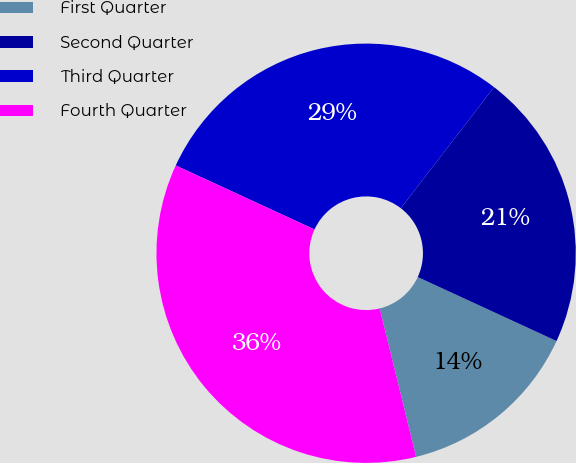<chart> <loc_0><loc_0><loc_500><loc_500><pie_chart><fcel>First Quarter<fcel>Second Quarter<fcel>Third Quarter<fcel>Fourth Quarter<nl><fcel>14.29%<fcel>21.43%<fcel>28.57%<fcel>35.71%<nl></chart> 